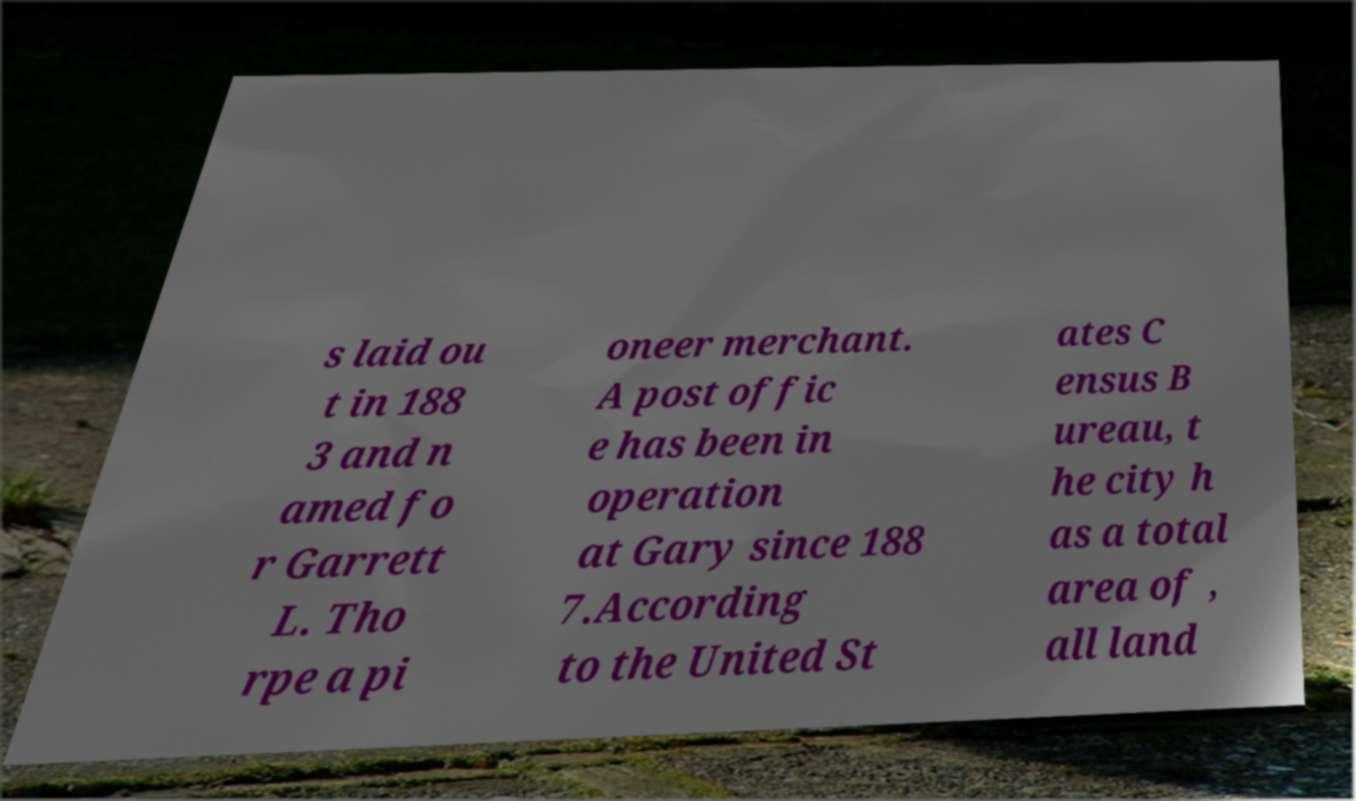Please identify and transcribe the text found in this image. s laid ou t in 188 3 and n amed fo r Garrett L. Tho rpe a pi oneer merchant. A post offic e has been in operation at Gary since 188 7.According to the United St ates C ensus B ureau, t he city h as a total area of , all land 